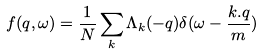<formula> <loc_0><loc_0><loc_500><loc_500>f ( { q } , \omega ) = \frac { 1 } { N } \sum _ { k } \Lambda _ { k } ( - { q } ) \delta ( \omega - \frac { k . q } { m } )</formula> 